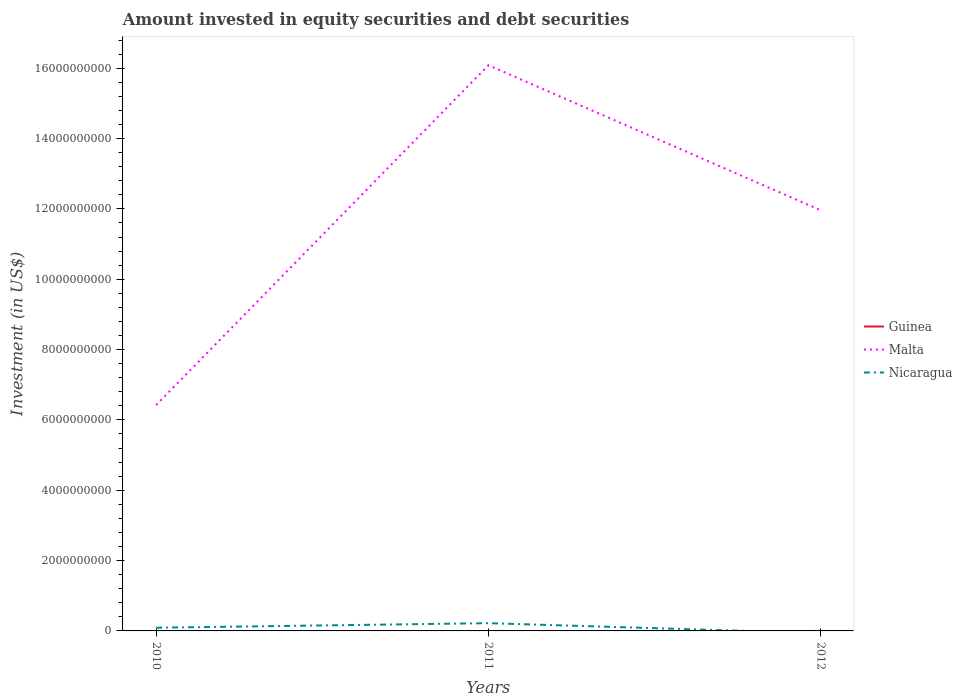Does the line corresponding to Guinea intersect with the line corresponding to Malta?
Provide a succinct answer. No. What is the total amount invested in equity securities and debt securities in Malta in the graph?
Provide a short and direct response. -9.66e+09. What is the difference between the highest and the second highest amount invested in equity securities and debt securities in Guinea?
Offer a terse response. 3.08e+06. What is the difference between the highest and the lowest amount invested in equity securities and debt securities in Guinea?
Provide a short and direct response. 1. Is the amount invested in equity securities and debt securities in Malta strictly greater than the amount invested in equity securities and debt securities in Nicaragua over the years?
Provide a succinct answer. No. How many years are there in the graph?
Your answer should be very brief. 3. What is the difference between two consecutive major ticks on the Y-axis?
Provide a short and direct response. 2.00e+09. Are the values on the major ticks of Y-axis written in scientific E-notation?
Offer a terse response. No. Does the graph contain any zero values?
Make the answer very short. Yes. Does the graph contain grids?
Provide a succinct answer. No. How many legend labels are there?
Your answer should be compact. 3. How are the legend labels stacked?
Your answer should be very brief. Vertical. What is the title of the graph?
Your answer should be very brief. Amount invested in equity securities and debt securities. What is the label or title of the X-axis?
Offer a terse response. Years. What is the label or title of the Y-axis?
Provide a short and direct response. Investment (in US$). What is the Investment (in US$) of Malta in 2010?
Provide a short and direct response. 6.42e+09. What is the Investment (in US$) in Nicaragua in 2010?
Offer a terse response. 9.11e+07. What is the Investment (in US$) of Malta in 2011?
Offer a very short reply. 1.61e+1. What is the Investment (in US$) of Nicaragua in 2011?
Ensure brevity in your answer.  2.20e+08. What is the Investment (in US$) of Guinea in 2012?
Ensure brevity in your answer.  3.08e+06. What is the Investment (in US$) in Malta in 2012?
Your answer should be compact. 1.20e+1. Across all years, what is the maximum Investment (in US$) of Guinea?
Offer a terse response. 3.08e+06. Across all years, what is the maximum Investment (in US$) of Malta?
Give a very brief answer. 1.61e+1. Across all years, what is the maximum Investment (in US$) of Nicaragua?
Your response must be concise. 2.20e+08. Across all years, what is the minimum Investment (in US$) in Guinea?
Give a very brief answer. 0. Across all years, what is the minimum Investment (in US$) in Malta?
Provide a short and direct response. 6.42e+09. What is the total Investment (in US$) in Guinea in the graph?
Offer a terse response. 3.08e+06. What is the total Investment (in US$) in Malta in the graph?
Provide a short and direct response. 3.45e+1. What is the total Investment (in US$) of Nicaragua in the graph?
Provide a short and direct response. 3.12e+08. What is the difference between the Investment (in US$) in Malta in 2010 and that in 2011?
Your answer should be very brief. -9.66e+09. What is the difference between the Investment (in US$) in Nicaragua in 2010 and that in 2011?
Your response must be concise. -1.29e+08. What is the difference between the Investment (in US$) in Malta in 2010 and that in 2012?
Give a very brief answer. -5.54e+09. What is the difference between the Investment (in US$) of Malta in 2011 and that in 2012?
Provide a short and direct response. 4.12e+09. What is the difference between the Investment (in US$) of Malta in 2010 and the Investment (in US$) of Nicaragua in 2011?
Your answer should be compact. 6.20e+09. What is the average Investment (in US$) in Guinea per year?
Keep it short and to the point. 1.03e+06. What is the average Investment (in US$) of Malta per year?
Keep it short and to the point. 1.15e+1. What is the average Investment (in US$) in Nicaragua per year?
Provide a succinct answer. 1.04e+08. In the year 2010, what is the difference between the Investment (in US$) of Malta and Investment (in US$) of Nicaragua?
Offer a terse response. 6.33e+09. In the year 2011, what is the difference between the Investment (in US$) of Malta and Investment (in US$) of Nicaragua?
Offer a very short reply. 1.59e+1. In the year 2012, what is the difference between the Investment (in US$) in Guinea and Investment (in US$) in Malta?
Your answer should be very brief. -1.20e+1. What is the ratio of the Investment (in US$) in Malta in 2010 to that in 2011?
Make the answer very short. 0.4. What is the ratio of the Investment (in US$) of Nicaragua in 2010 to that in 2011?
Give a very brief answer. 0.41. What is the ratio of the Investment (in US$) in Malta in 2010 to that in 2012?
Offer a terse response. 0.54. What is the ratio of the Investment (in US$) of Malta in 2011 to that in 2012?
Your response must be concise. 1.34. What is the difference between the highest and the second highest Investment (in US$) of Malta?
Ensure brevity in your answer.  4.12e+09. What is the difference between the highest and the lowest Investment (in US$) in Guinea?
Provide a succinct answer. 3.08e+06. What is the difference between the highest and the lowest Investment (in US$) of Malta?
Your answer should be very brief. 9.66e+09. What is the difference between the highest and the lowest Investment (in US$) in Nicaragua?
Your answer should be very brief. 2.20e+08. 